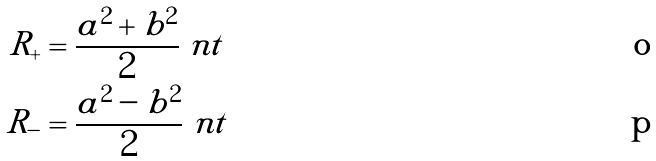Convert formula to latex. <formula><loc_0><loc_0><loc_500><loc_500>R _ { + } & = \frac { a ^ { 2 } + b ^ { 2 } } { 2 } \ n t \\ R _ { - } & = \frac { a ^ { 2 } - b ^ { 2 } } { 2 } \ n t</formula> 